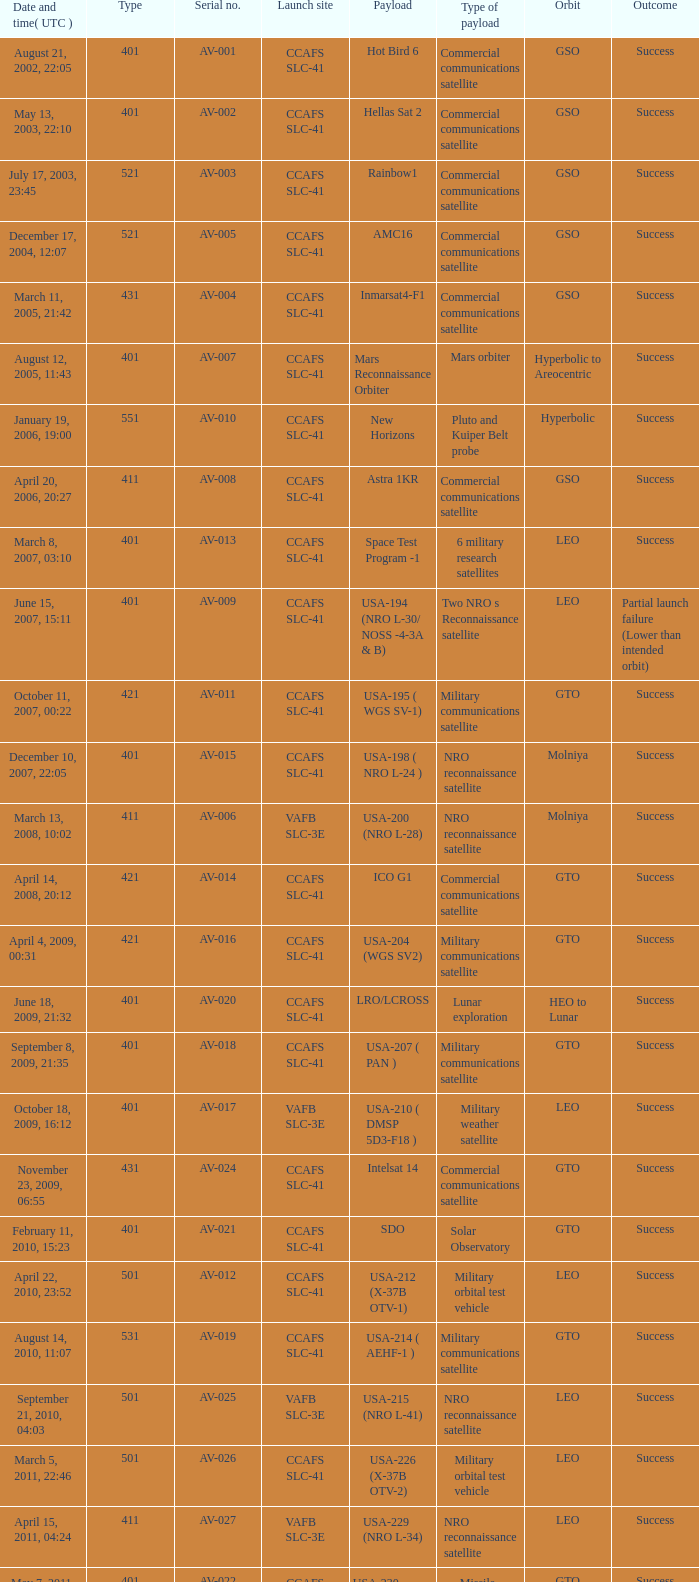When was the freight of commercial communications satellite amc16? December 17, 2004, 12:07. 